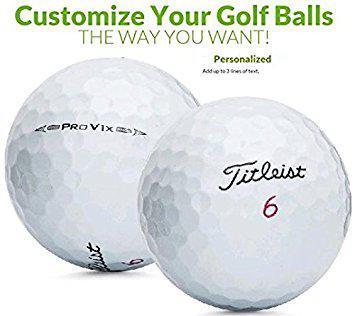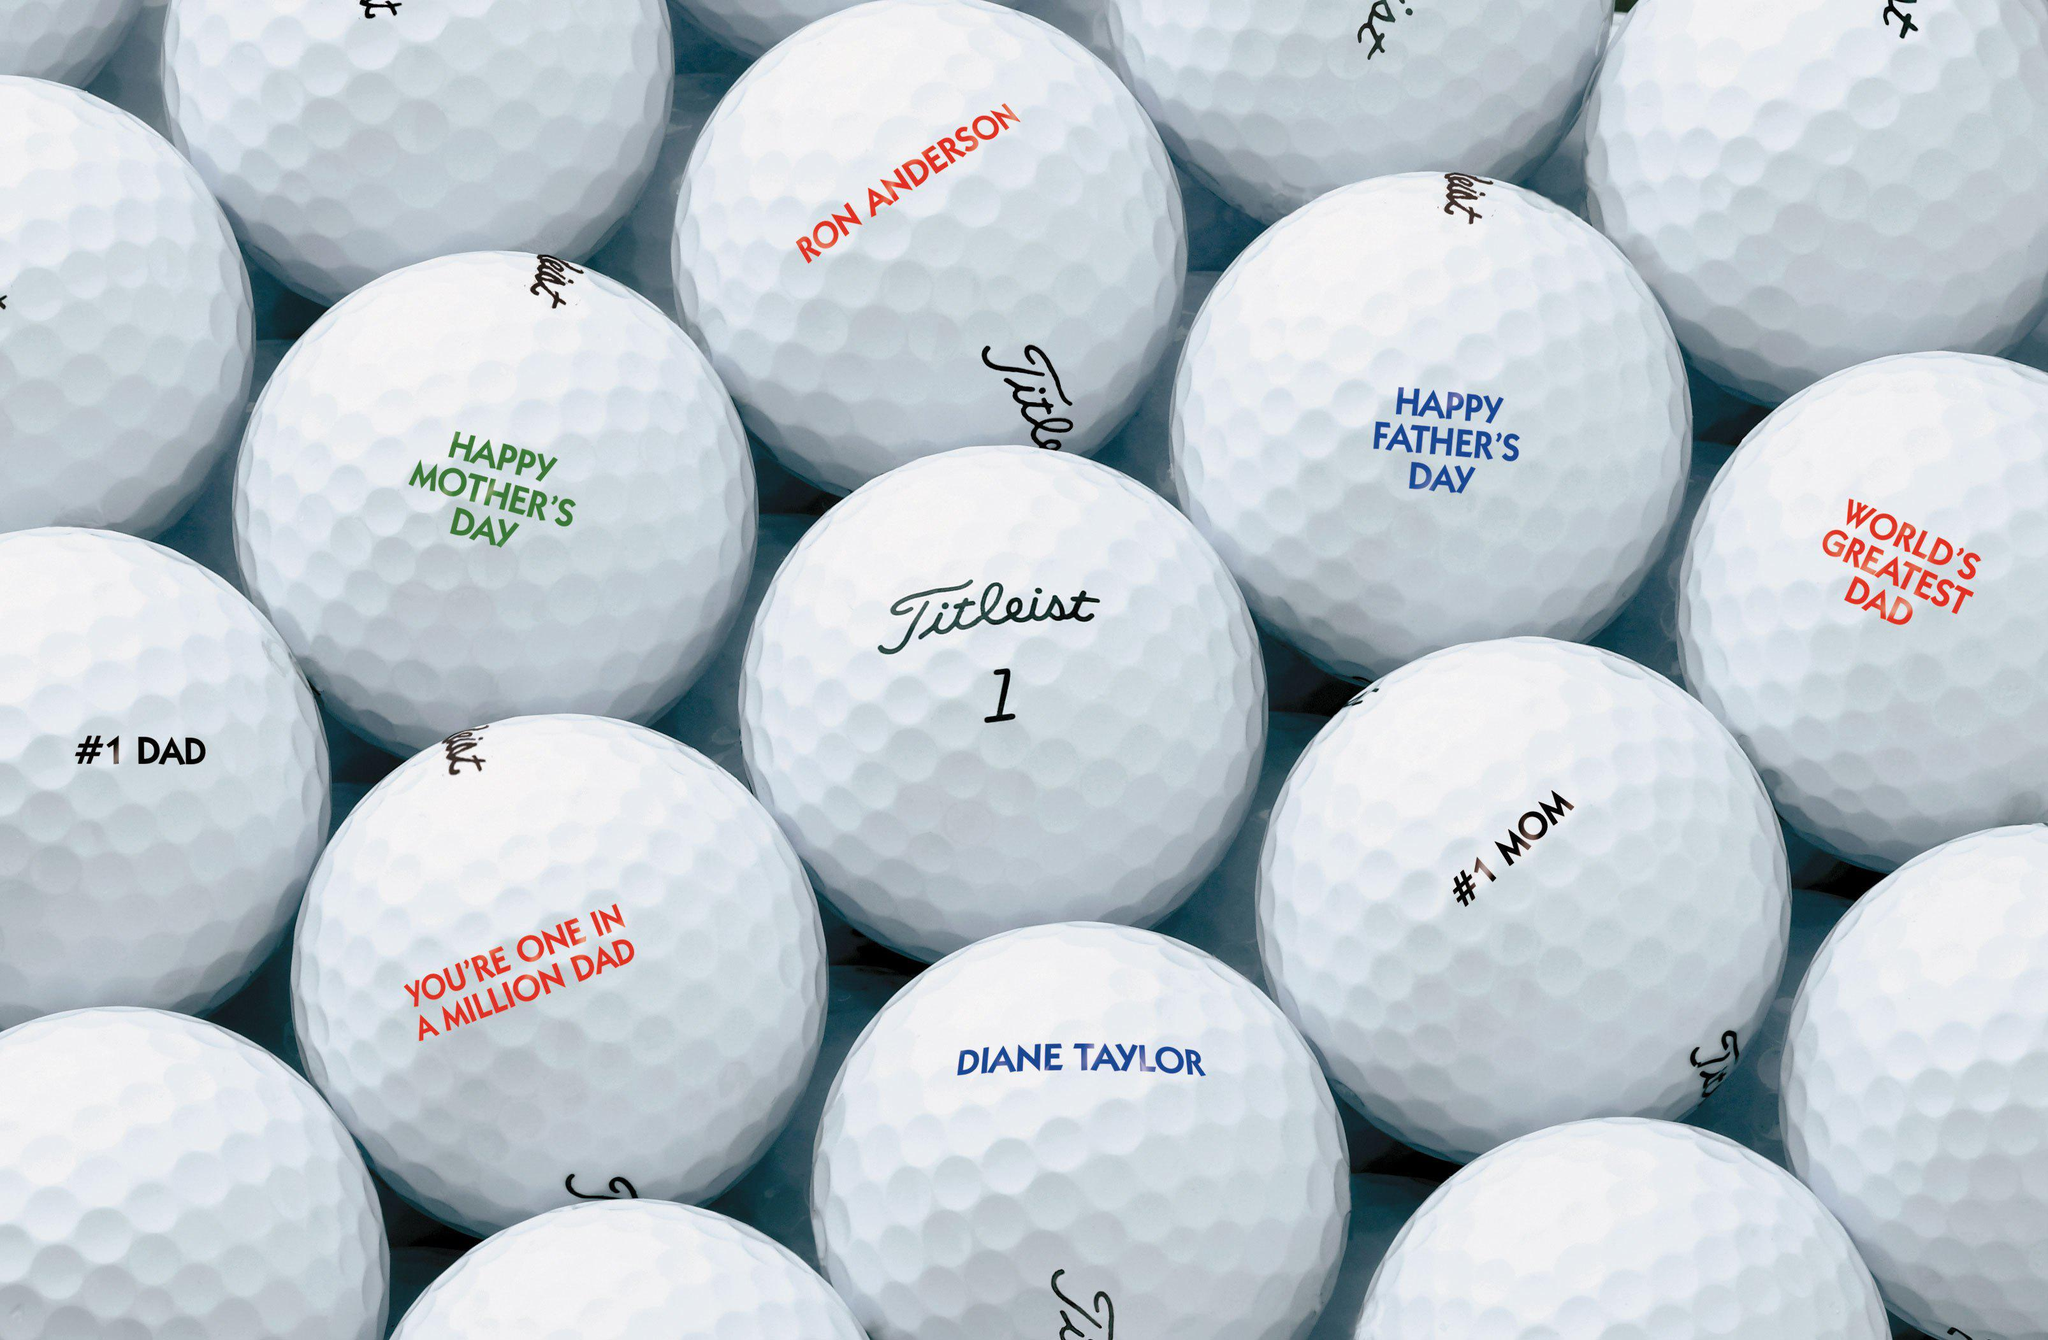The first image is the image on the left, the second image is the image on the right. For the images shown, is this caption "The combined images contain exactly six white golf balls." true? Answer yes or no. No. The first image is the image on the left, the second image is the image on the right. Assess this claim about the two images: "The left and right image contains a total of six golf balls.". Correct or not? Answer yes or no. No. 